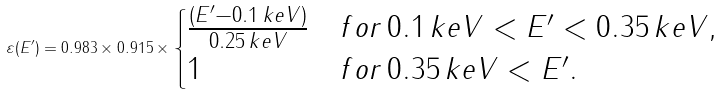<formula> <loc_0><loc_0><loc_500><loc_500>\varepsilon ( E ^ { \prime } ) = 0 . 9 8 3 \times 0 . 9 1 5 \times \begin{cases} \frac { ( E ^ { \prime } - 0 . 1 \, k e V ) } { 0 . 2 5 \, k e V } & f o r \, 0 . 1 \, k e V < E ^ { \prime } < 0 . 3 5 \, k e V , \\ 1 & f o r \, 0 . 3 5 \, k e V < E ^ { \prime } . \end{cases}</formula> 